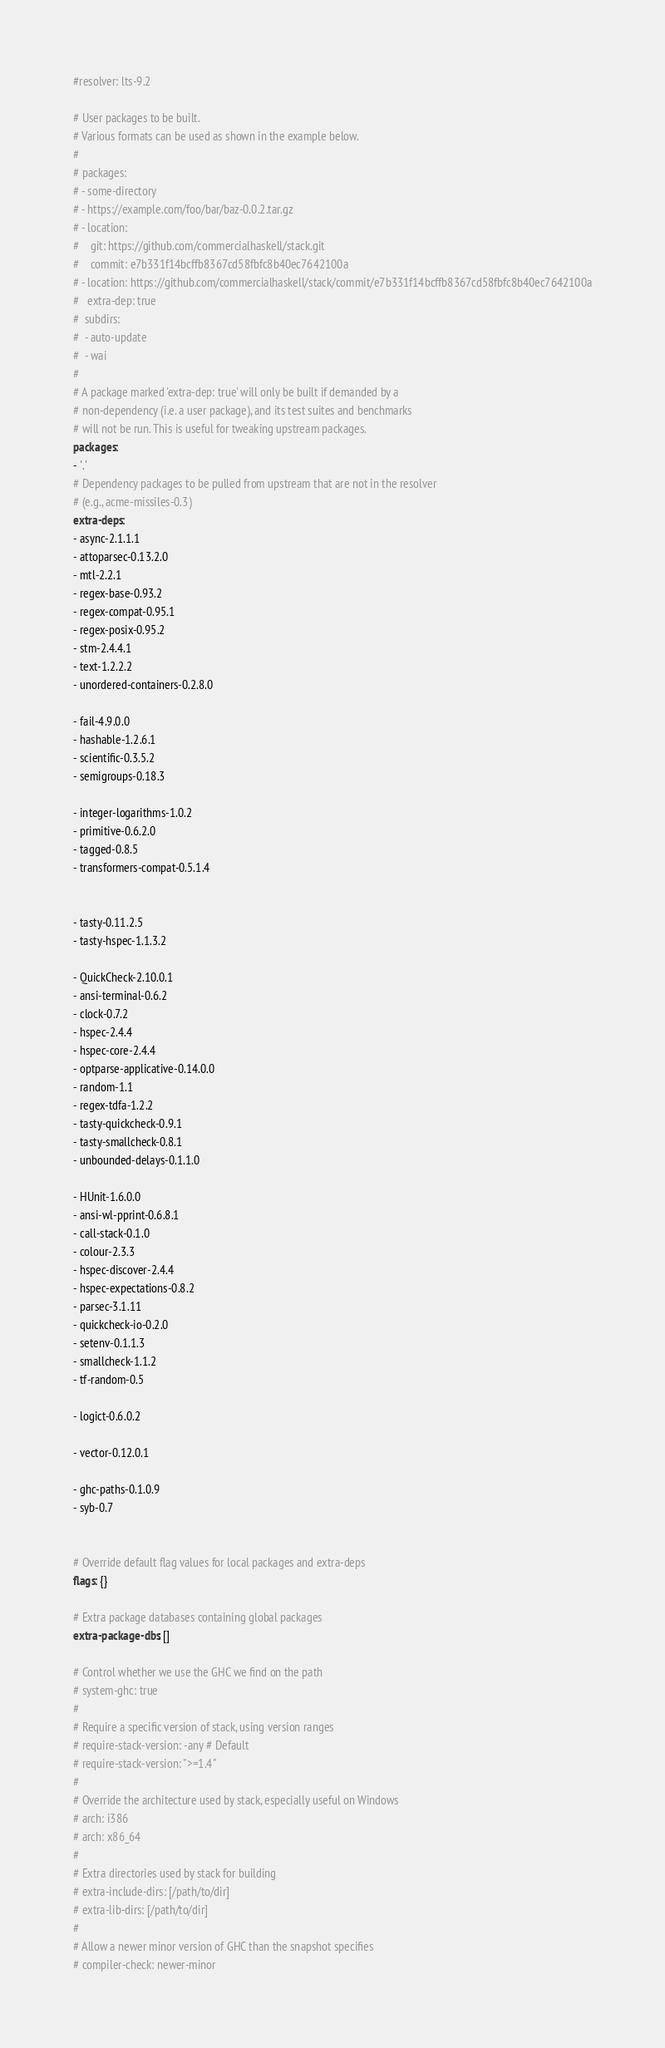Convert code to text. <code><loc_0><loc_0><loc_500><loc_500><_YAML_>#resolver: lts-9.2

# User packages to be built.
# Various formats can be used as shown in the example below.
#
# packages:
# - some-directory
# - https://example.com/foo/bar/baz-0.0.2.tar.gz
# - location:
#    git: https://github.com/commercialhaskell/stack.git
#    commit: e7b331f14bcffb8367cd58fbfc8b40ec7642100a
# - location: https://github.com/commercialhaskell/stack/commit/e7b331f14bcffb8367cd58fbfc8b40ec7642100a
#   extra-dep: true
#  subdirs:
#  - auto-update
#  - wai
#
# A package marked 'extra-dep: true' will only be built if demanded by a
# non-dependency (i.e. a user package), and its test suites and benchmarks
# will not be run. This is useful for tweaking upstream packages.
packages:
- '.'
# Dependency packages to be pulled from upstream that are not in the resolver
# (e.g., acme-missiles-0.3)
extra-deps: 
- async-2.1.1.1
- attoparsec-0.13.2.0
- mtl-2.2.1
- regex-base-0.93.2
- regex-compat-0.95.1
- regex-posix-0.95.2
- stm-2.4.4.1
- text-1.2.2.2
- unordered-containers-0.2.8.0

- fail-4.9.0.0
- hashable-1.2.6.1
- scientific-0.3.5.2
- semigroups-0.18.3

- integer-logarithms-1.0.2
- primitive-0.6.2.0
- tagged-0.8.5
- transformers-compat-0.5.1.4


- tasty-0.11.2.5
- tasty-hspec-1.1.3.2

- QuickCheck-2.10.0.1
- ansi-terminal-0.6.2
- clock-0.7.2
- hspec-2.4.4
- hspec-core-2.4.4
- optparse-applicative-0.14.0.0
- random-1.1
- regex-tdfa-1.2.2
- tasty-quickcheck-0.9.1
- tasty-smallcheck-0.8.1
- unbounded-delays-0.1.1.0

- HUnit-1.6.0.0
- ansi-wl-pprint-0.6.8.1
- call-stack-0.1.0
- colour-2.3.3
- hspec-discover-2.4.4
- hspec-expectations-0.8.2
- parsec-3.1.11
- quickcheck-io-0.2.0
- setenv-0.1.1.3
- smallcheck-1.1.2
- tf-random-0.5

- logict-0.6.0.2

- vector-0.12.0.1

- ghc-paths-0.1.0.9
- syb-0.7


# Override default flag values for local packages and extra-deps
flags: {}

# Extra package databases containing global packages
extra-package-dbs: []

# Control whether we use the GHC we find on the path
# system-ghc: true
#
# Require a specific version of stack, using version ranges
# require-stack-version: -any # Default
# require-stack-version: ">=1.4"
#
# Override the architecture used by stack, especially useful on Windows
# arch: i386
# arch: x86_64
#
# Extra directories used by stack for building
# extra-include-dirs: [/path/to/dir]
# extra-lib-dirs: [/path/to/dir]
#
# Allow a newer minor version of GHC than the snapshot specifies
# compiler-check: newer-minor</code> 